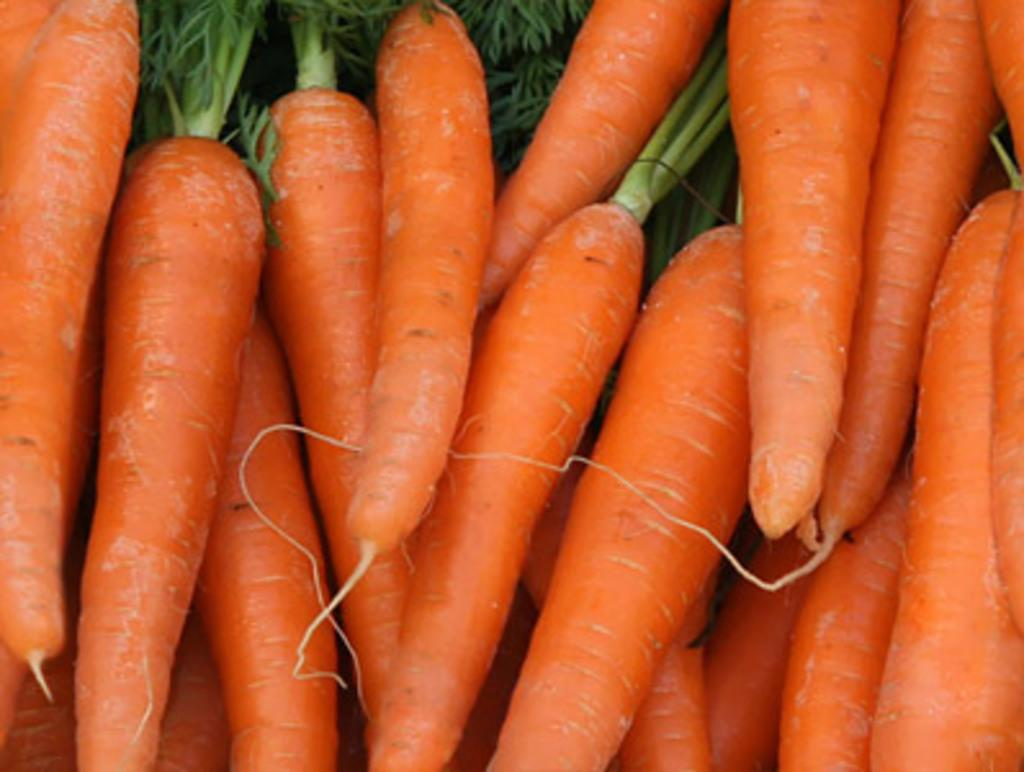What type of vegetables are present in the image? There are many orange carrots in the image. What part of the carrots can be seen in the image? The carrots have leaves in the image. How many parents are visible in the image? There are no parents present in the image, as it features only orange carrots with leaves. 